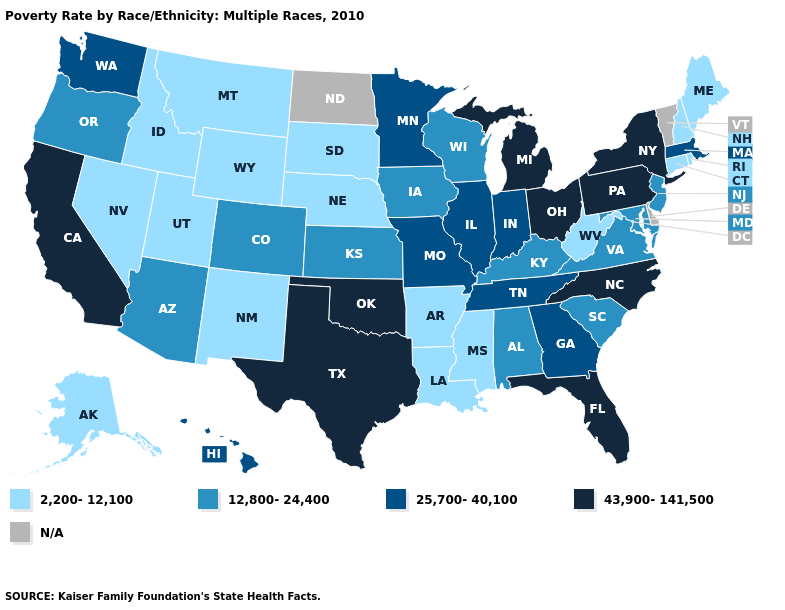Which states have the highest value in the USA?
Concise answer only. California, Florida, Michigan, New York, North Carolina, Ohio, Oklahoma, Pennsylvania, Texas. What is the value of Illinois?
Quick response, please. 25,700-40,100. What is the lowest value in the West?
Write a very short answer. 2,200-12,100. What is the lowest value in the USA?
Short answer required. 2,200-12,100. Which states have the lowest value in the USA?
Answer briefly. Alaska, Arkansas, Connecticut, Idaho, Louisiana, Maine, Mississippi, Montana, Nebraska, Nevada, New Hampshire, New Mexico, Rhode Island, South Dakota, Utah, West Virginia, Wyoming. Name the states that have a value in the range 2,200-12,100?
Answer briefly. Alaska, Arkansas, Connecticut, Idaho, Louisiana, Maine, Mississippi, Montana, Nebraska, Nevada, New Hampshire, New Mexico, Rhode Island, South Dakota, Utah, West Virginia, Wyoming. What is the value of Maine?
Keep it brief. 2,200-12,100. What is the value of New Jersey?
Answer briefly. 12,800-24,400. What is the value of Kentucky?
Give a very brief answer. 12,800-24,400. Which states have the lowest value in the South?
Write a very short answer. Arkansas, Louisiana, Mississippi, West Virginia. How many symbols are there in the legend?
Be succinct. 5. What is the value of Washington?
Write a very short answer. 25,700-40,100. What is the lowest value in the West?
Concise answer only. 2,200-12,100. What is the value of New York?
Short answer required. 43,900-141,500. 